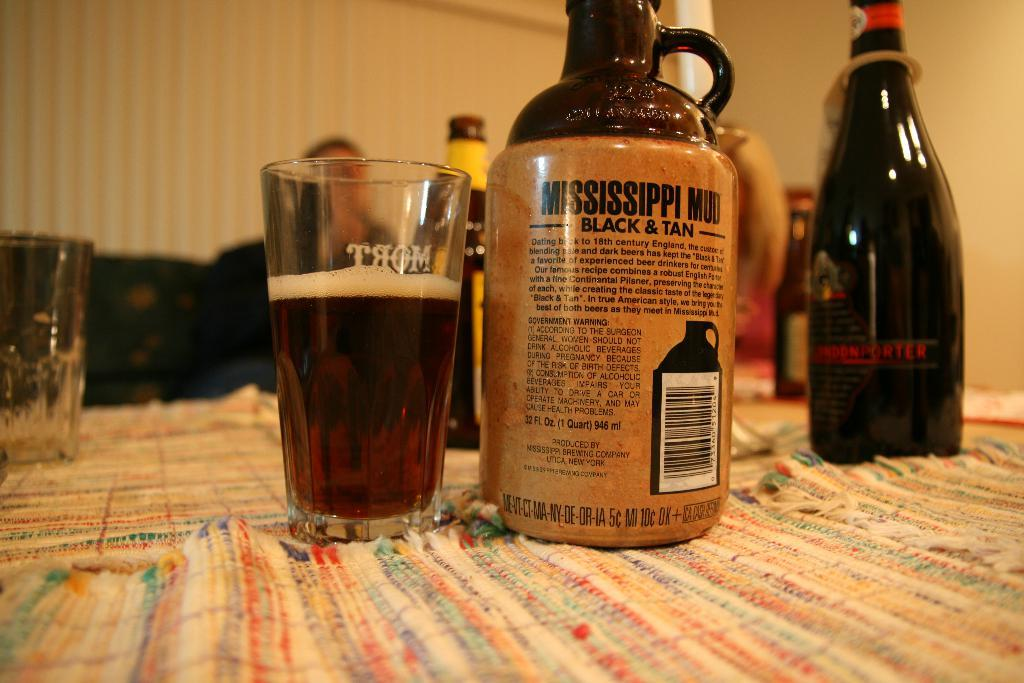<image>
Share a concise interpretation of the image provided. Jug of Mississippi Mud sits next to a glass full on a table with other bottles. 